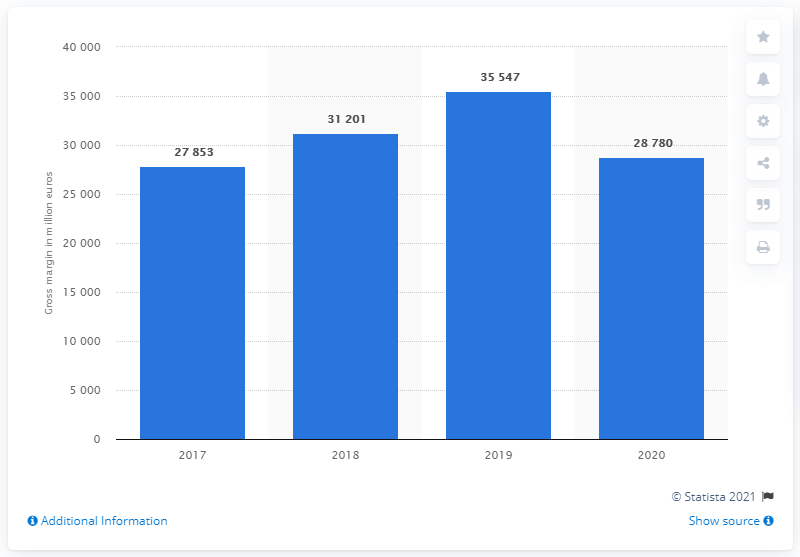Give some essential details in this illustration. In 2020, LVMH's gross margin was 28,780. 